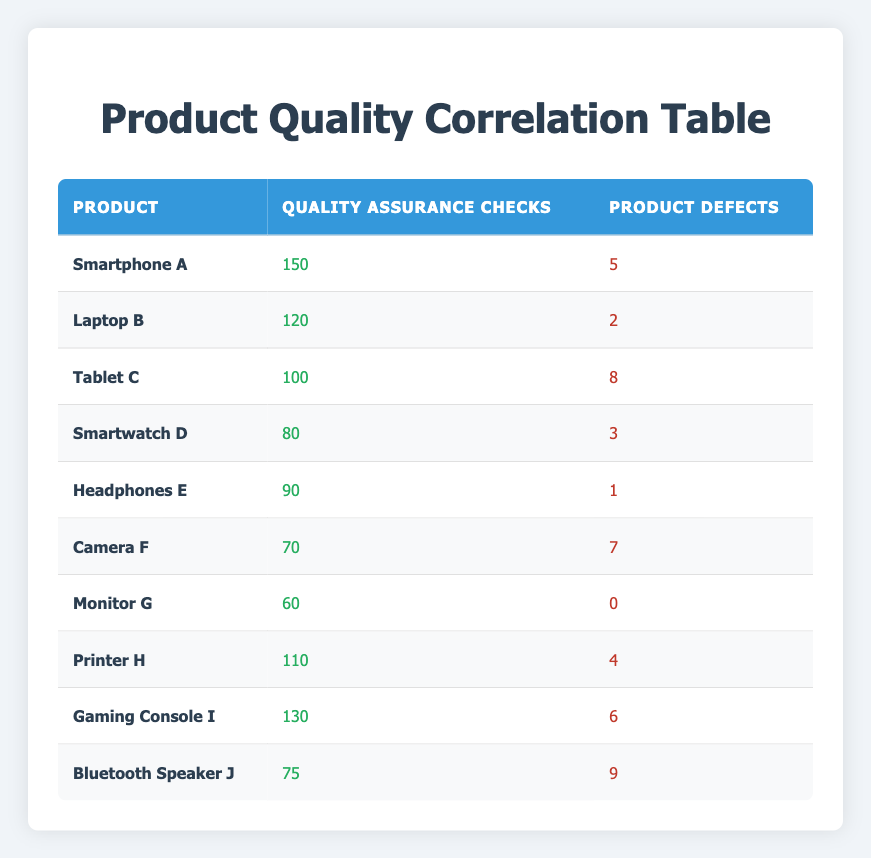What is the number of product defects for Smartphone A? According to the table, Smartphone A has 5 product defects listed under the "Product Defects" column.
Answer: 5 Which product had the highest number of quality assurance checks conducted? Reviewing the "Quality Assurance Checks Conducted" column, Smartphone A tops the list with 150 checks conducted, which is more than any other product listed.
Answer: Smartphone A How many products have more than 5 product defects? Upon checking the "Product Defects" column, only Bluetooth Speaker J (9 defects) and Tablet C (8 defects) exceed 5 defects; therefore, there are 2 products with more than 5 defects.
Answer: 2 What is the average number of quality assurance checks conducted across all products? Adding all the quality assurance checks: 150 + 120 + 100 + 80 + 90 + 70 + 60 + 110 + 130 + 75 = 1,005. Dividing this total by the 10 products gives an average of 1,005 / 10 = 100.5.
Answer: 100.5 Is it true that the Monitor G has zero product defects? The table clearly shows that Monitor G has a recorded number of 0 in the "Product Defects" column, confirming that this statement is true.
Answer: Yes Which product had the second-highest product defects, and how many defects did it have? By examining the "Product Defects" column, we notice Bluetooth Speaker J had the highest (9), while Tablet C comes second with 8 defects. Therefore, Tablet C is the product with the second-highest defects.
Answer: Tablet C, 8 defects What is the total number of product defects from all products combined? To find the total product defects, we sum each defect count: 5 + 2 + 8 + 3 + 1 + 7 + 0 + 4 + 6 + 9 = 45. Thus, the total number of product defects across all products is 45.
Answer: 45 How many quality assurance checks were conducted for Laptop B and Printer H combined? Adding the checks for both products, Laptop B had 120 checks and Printer H had 110 checks, resulting in 120 + 110 = 230 checks combined.
Answer: 230 Are there any products that have a lower number of quality assurance checks than the number of product defects? By reviewing the table, we observe that Camera F has 70 checks and 7 defects. Additionally, Bluetooth Speaker J has 75 checks and 9 defects. Both exhibit more defects than checks. Hence, the answer is yes.
Answer: Yes 